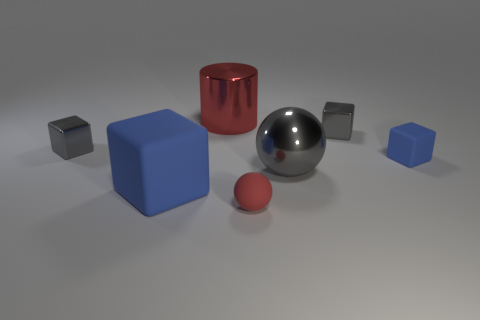Could you describe the relative positions of the objects? Certainly. Central to the image is a large silver sphere, with a red cylinder to its right. In front of the silver sphere is a small red sphere, and scattered around these central figures are three blue cubes at various distances. The cubes and spheres are shown on a flat surface with a horizon line slightly visible in the background. 